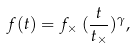<formula> <loc_0><loc_0><loc_500><loc_500>f ( t ) = f _ { \times } \, ( \frac { t } { t _ { \times } } ) ^ { \gamma } ,</formula> 